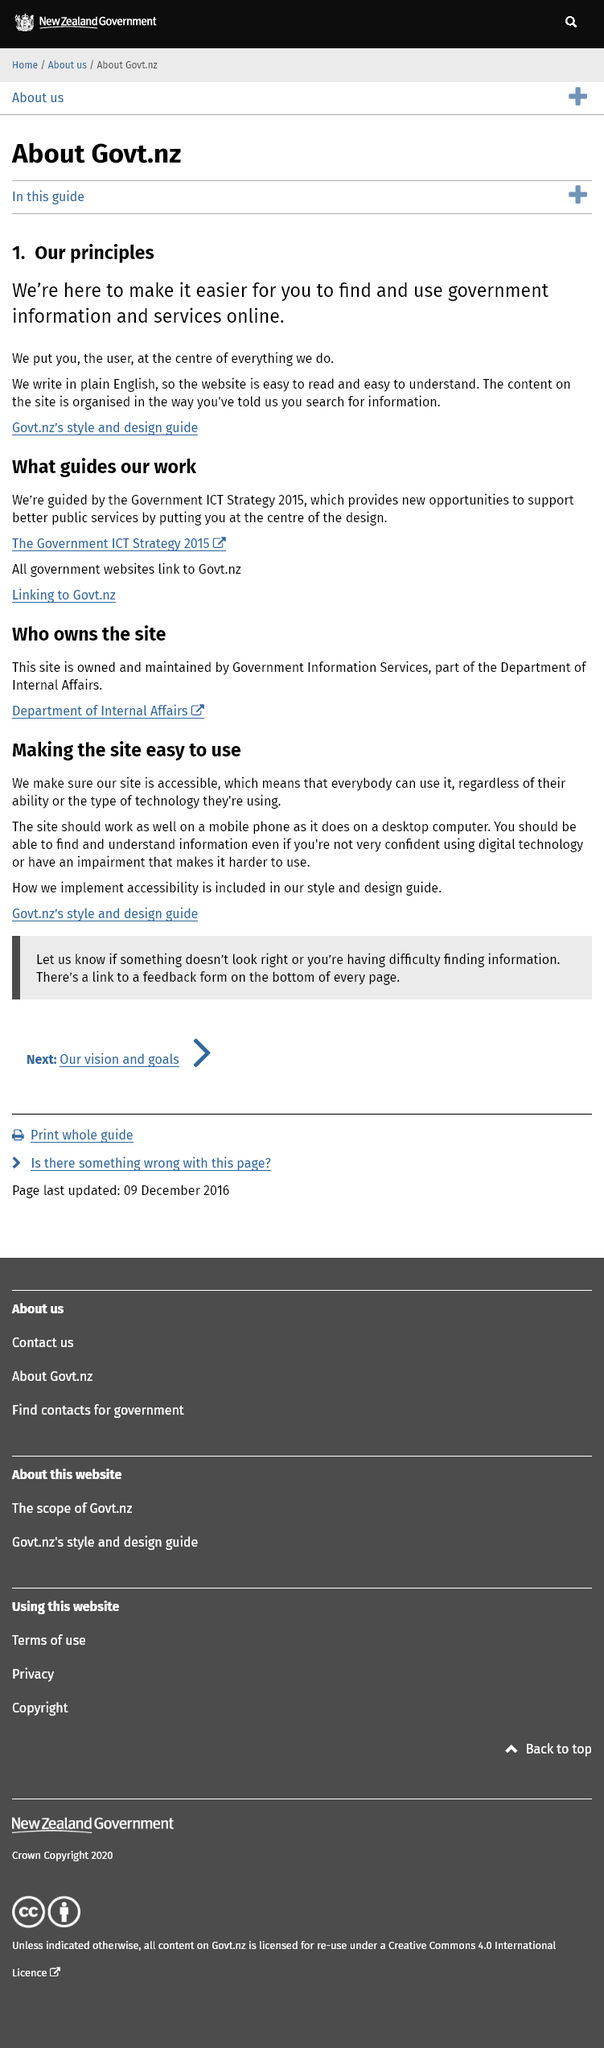List a handful of essential elements in this visual. The government.nz website prioritizes the user and positions them at the center of its operations. The Govt.nz website is guided by the Government ICT Strategy 2015, a strategic document that outlines the guidelines for the website's work. The Govt.nz website's commitment to writing in plain English is a principle that ensures its website is easily readable and understandable to users. 